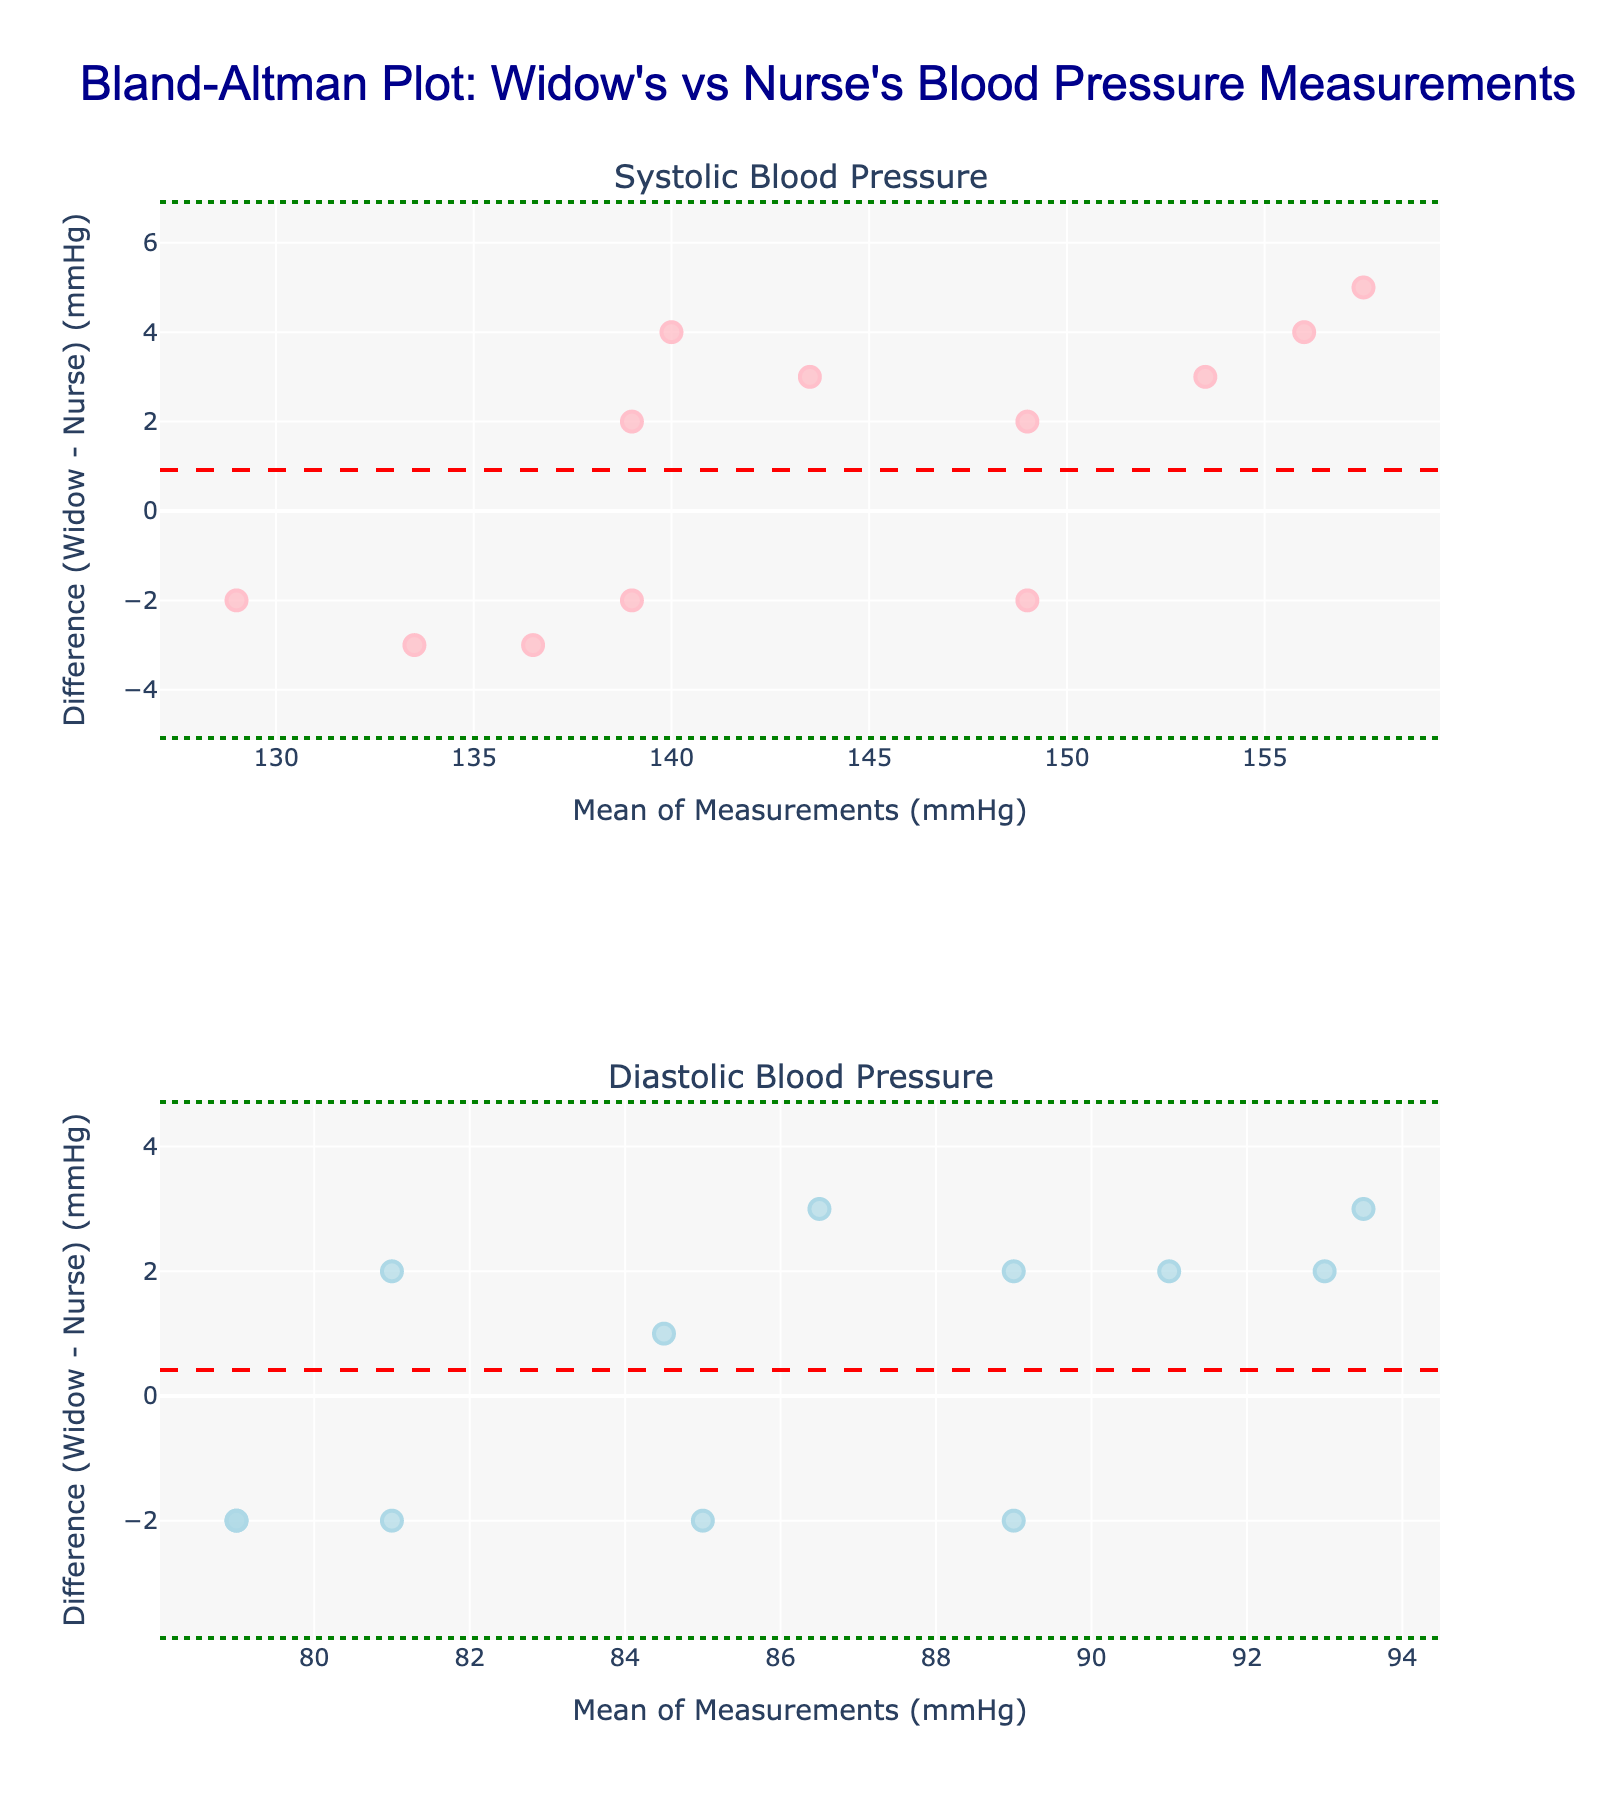what is the mean difference in systolic blood pressure measurements? The mean difference in systolic blood pressure measurements can be found directly by referring to the horizontal dashed red line in the upper plot.
Answer: approximately 2.0 mmHg What is the range of the limits of agreement for the diastolic measurements? The range of limits of agreement can be identified by subtracting the lower limit from the upper limit. These limits are represented by the horizontal green dotted lines in the lower plot. The upper limit is around +2.33 mmHg and the lower limit is around -2.33 mmHg. So, the range is 2.33 - (-2.33) = 4.66 mmHg
Answer: 4.66 mmHg How many data points fall outside the limits of agreement in the systolic measurements? To determine this, count the number of points that are placed outside the upper and lower green dotted lines on the upper plot.
Answer: 0 What's the largest difference in systolic readings observed? Find the largest positive or negative value on the y-axis of the upper plot, which represents the difference between the widow's and the nurse's systolic readings. The maximum difference visually appears to be around 5 mmHg.
Answer: 5 mmHg Are the widow's diastolic readings generally higher, lower, or about the same as the nurse's readings? Referring to the lower plot's scatter points and their distribution around the y=0 line, if most points are above or below this line, it reveals the trend in differences. Most points are near the 0 line, indicating the widow's diastolic readings are about the same as the nurse's readings.
Answer: About the same 